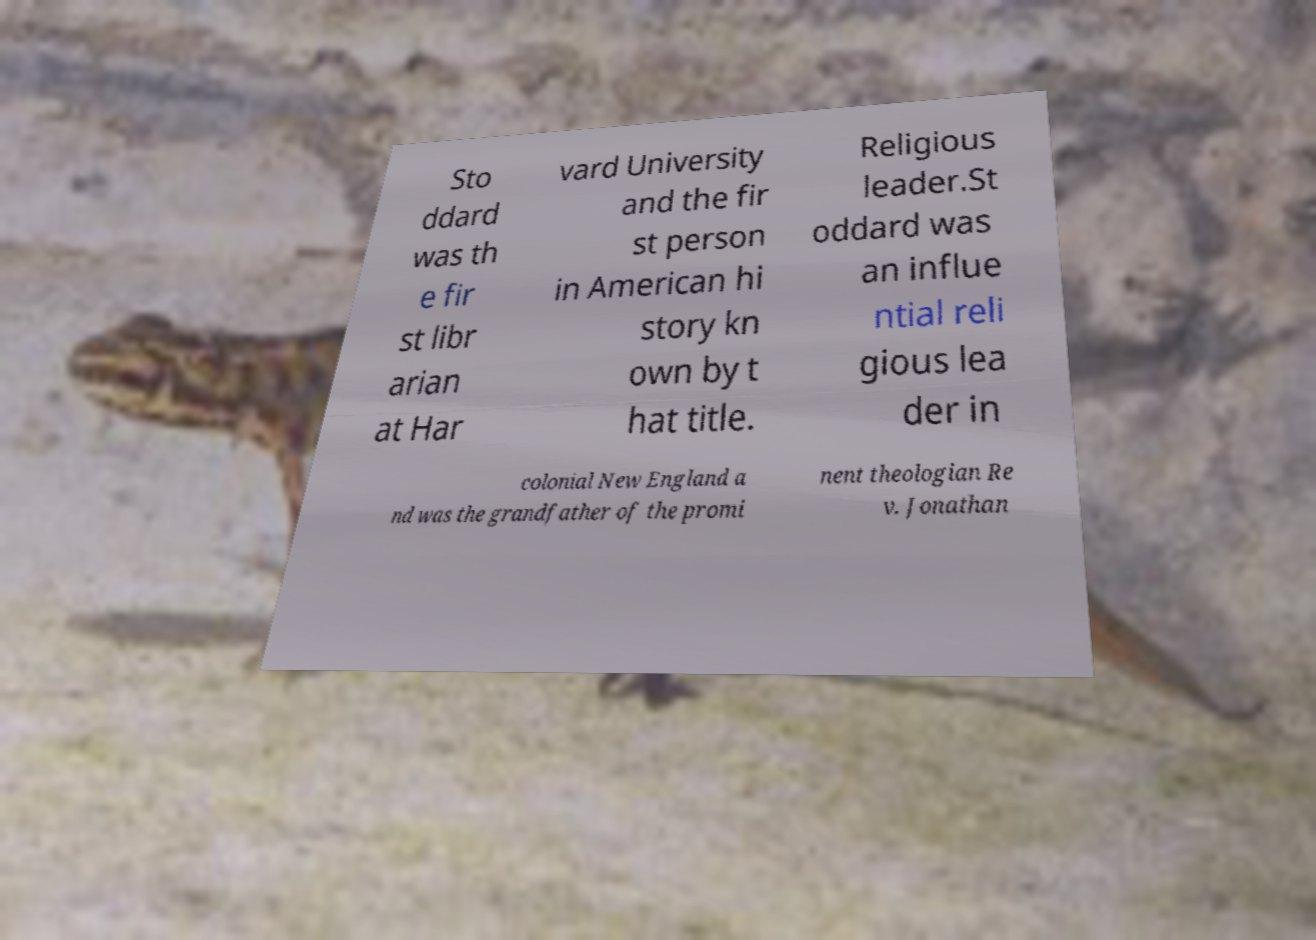Please identify and transcribe the text found in this image. Sto ddard was th e fir st libr arian at Har vard University and the fir st person in American hi story kn own by t hat title. Religious leader.St oddard was an influe ntial reli gious lea der in colonial New England a nd was the grandfather of the promi nent theologian Re v. Jonathan 